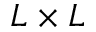<formula> <loc_0><loc_0><loc_500><loc_500>L \times L</formula> 